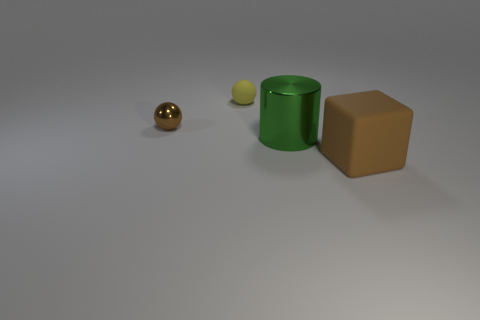What color is the big cylinder? green 